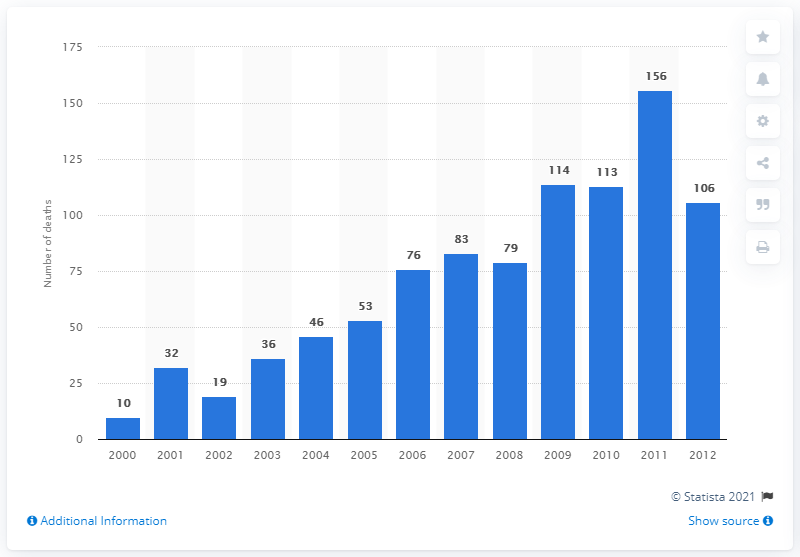Indicate a few pertinent items in this graphic. In 2011, there were 156 reported deaths related to tramadol use. 